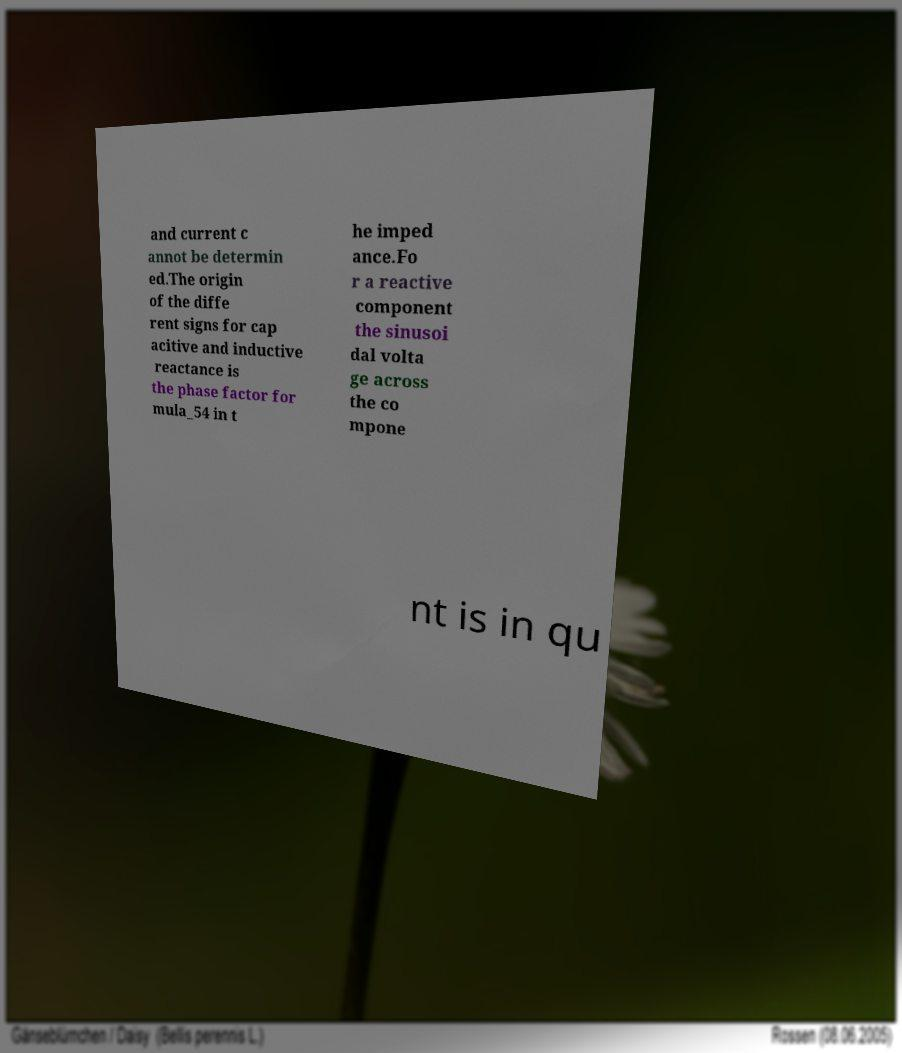What messages or text are displayed in this image? I need them in a readable, typed format. and current c annot be determin ed.The origin of the diffe rent signs for cap acitive and inductive reactance is the phase factor for mula_54 in t he imped ance.Fo r a reactive component the sinusoi dal volta ge across the co mpone nt is in qu 